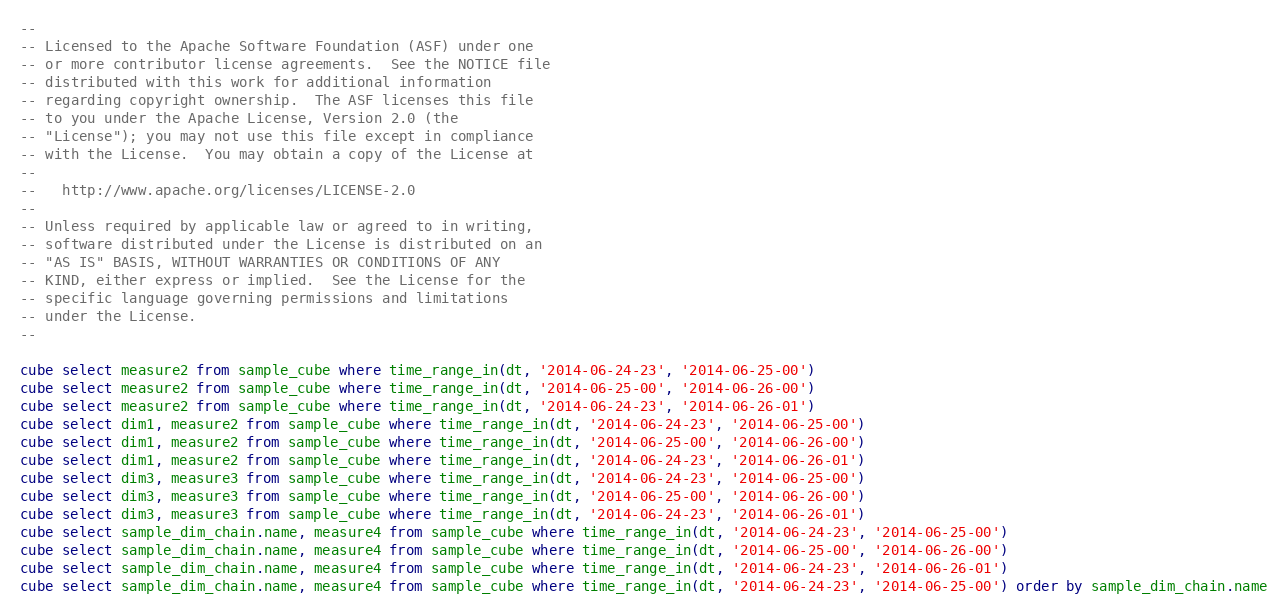<code> <loc_0><loc_0><loc_500><loc_500><_SQL_>--
-- Licensed to the Apache Software Foundation (ASF) under one
-- or more contributor license agreements.  See the NOTICE file
-- distributed with this work for additional information
-- regarding copyright ownership.  The ASF licenses this file
-- to you under the Apache License, Version 2.0 (the
-- "License"); you may not use this file except in compliance
-- with the License.  You may obtain a copy of the License at
--
--   http://www.apache.org/licenses/LICENSE-2.0
--
-- Unless required by applicable law or agreed to in writing,
-- software distributed under the License is distributed on an
-- "AS IS" BASIS, WITHOUT WARRANTIES OR CONDITIONS OF ANY
-- KIND, either express or implied.  See the License for the
-- specific language governing permissions and limitations
-- under the License.
--

cube select measure2 from sample_cube where time_range_in(dt, '2014-06-24-23', '2014-06-25-00')
cube select measure2 from sample_cube where time_range_in(dt, '2014-06-25-00', '2014-06-26-00')
cube select measure2 from sample_cube where time_range_in(dt, '2014-06-24-23', '2014-06-26-01')
cube select dim1, measure2 from sample_cube where time_range_in(dt, '2014-06-24-23', '2014-06-25-00')
cube select dim1, measure2 from sample_cube where time_range_in(dt, '2014-06-25-00', '2014-06-26-00')
cube select dim1, measure2 from sample_cube where time_range_in(dt, '2014-06-24-23', '2014-06-26-01')
cube select dim3, measure3 from sample_cube where time_range_in(dt, '2014-06-24-23', '2014-06-25-00')
cube select dim3, measure3 from sample_cube where time_range_in(dt, '2014-06-25-00', '2014-06-26-00')
cube select dim3, measure3 from sample_cube where time_range_in(dt, '2014-06-24-23', '2014-06-26-01')
cube select sample_dim_chain.name, measure4 from sample_cube where time_range_in(dt, '2014-06-24-23', '2014-06-25-00')
cube select sample_dim_chain.name, measure4 from sample_cube where time_range_in(dt, '2014-06-25-00', '2014-06-26-00')
cube select sample_dim_chain.name, measure4 from sample_cube where time_range_in(dt, '2014-06-24-23', '2014-06-26-01')
cube select sample_dim_chain.name, measure4 from sample_cube where time_range_in(dt, '2014-06-24-23', '2014-06-25-00') order by sample_dim_chain.name</code> 